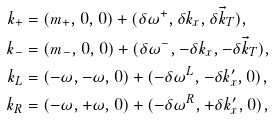<formula> <loc_0><loc_0><loc_500><loc_500>k _ { + } & = ( m _ { + } , 0 , 0 ) + ( \delta \omega ^ { + } , \delta k _ { x } , \delta { \vec { k } } _ { T } ) , \\ k _ { - } & = ( m _ { - } , 0 , 0 ) + ( \delta \omega ^ { - } , - \delta k _ { x } , - \delta { \vec { k } } _ { T } ) , \\ k _ { L } & = ( - \omega , - \omega , 0 ) + ( - \delta \omega ^ { L } , - \delta k ^ { \prime } _ { x } , 0 ) , \\ k _ { R } & = ( - \omega , + \omega , 0 ) + ( - \delta \omega ^ { R } , + \delta k ^ { \prime } _ { x } , 0 ) ,</formula> 